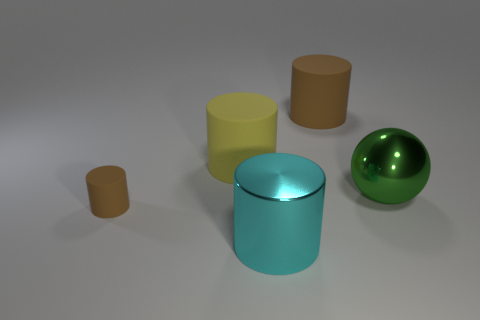Is there any indication about the lighting source in this scene? Yes, the lighting in the scene suggests a soft, diffused overhead light source. This is evident by the gentle shadows cast beneath and to the right of the objects, suggesting a light source located above and slightly to the left. 